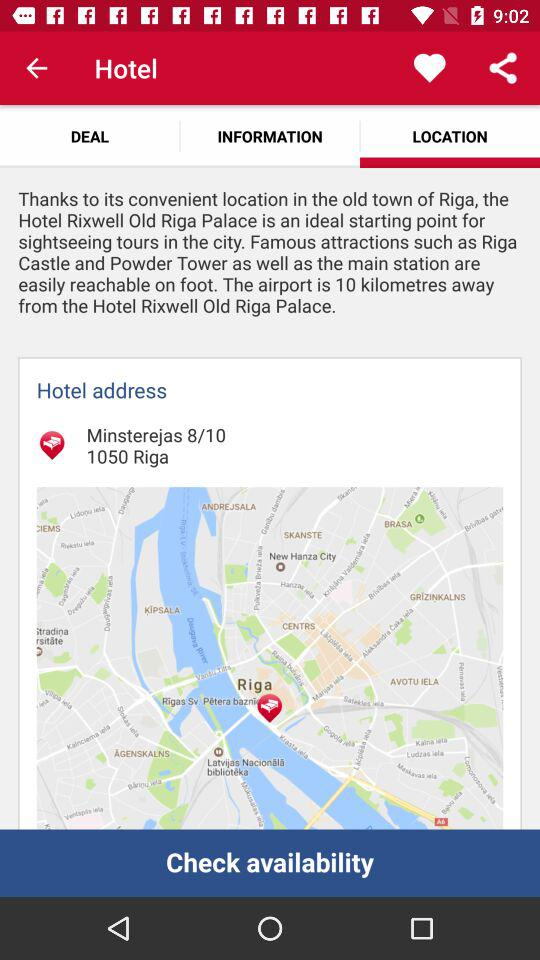How many kilometers away from the hotel is the airport?
Answer the question using a single word or phrase. 10 